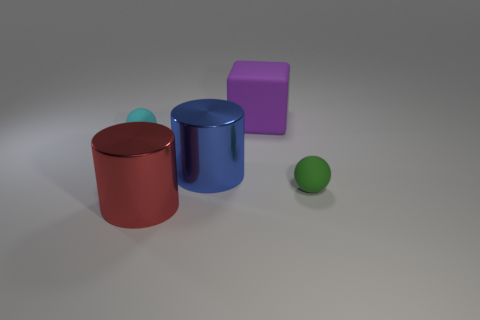There is a sphere that is to the left of the big cube; what is it made of?
Give a very brief answer. Rubber. How many objects are large red metallic cylinders or large blue shiny cylinders?
Ensure brevity in your answer.  2. What number of other things are there of the same shape as the purple object?
Ensure brevity in your answer.  0. Is the tiny ball that is on the right side of the cube made of the same material as the tiny thing behind the blue thing?
Offer a terse response. Yes. The rubber thing that is both right of the cyan ball and behind the large blue shiny object has what shape?
Give a very brief answer. Cube. What is the material of the object that is both to the left of the large blue object and in front of the tiny cyan sphere?
Provide a succinct answer. Metal. There is a small object that is the same material as the green ball; what shape is it?
Make the answer very short. Sphere. Is there anything else of the same color as the large block?
Your response must be concise. No. Is the number of rubber objects that are in front of the blue thing greater than the number of tiny green matte spheres?
Make the answer very short. No. What is the material of the big purple cube?
Offer a very short reply. Rubber. 